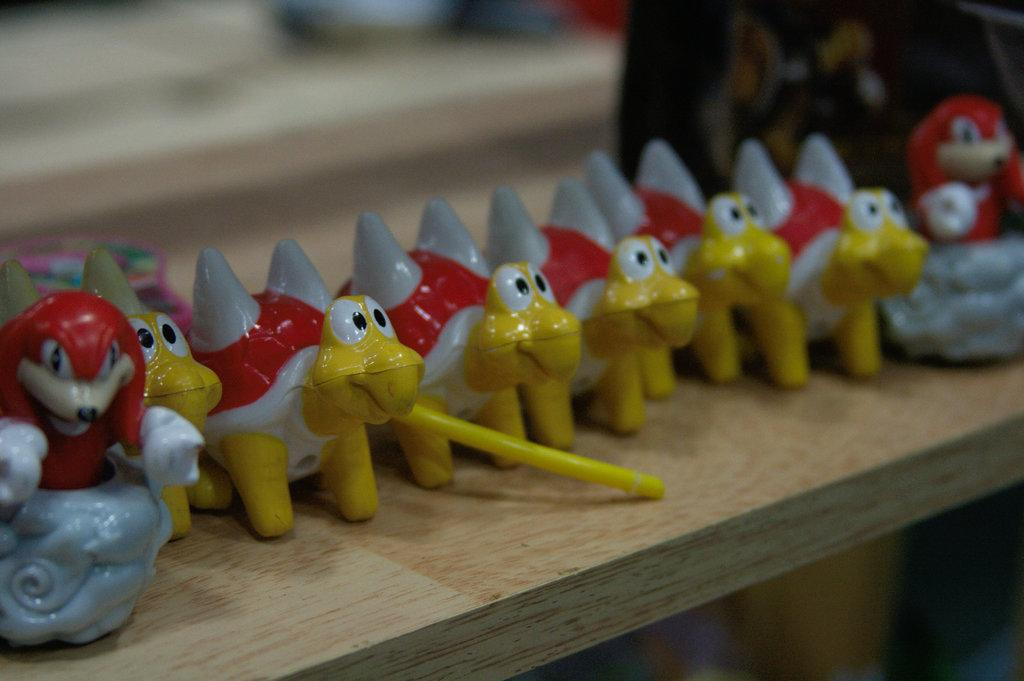What is located in the center of the image? There is a table in the middle of the image. What is placed on the table? There are toys on the table. Can you describe the background of the image? The background of the image is blurred. What type of coal is being used to make the creamy rice dish in the image? There is no coal, cream, or rice dish present in the image. 